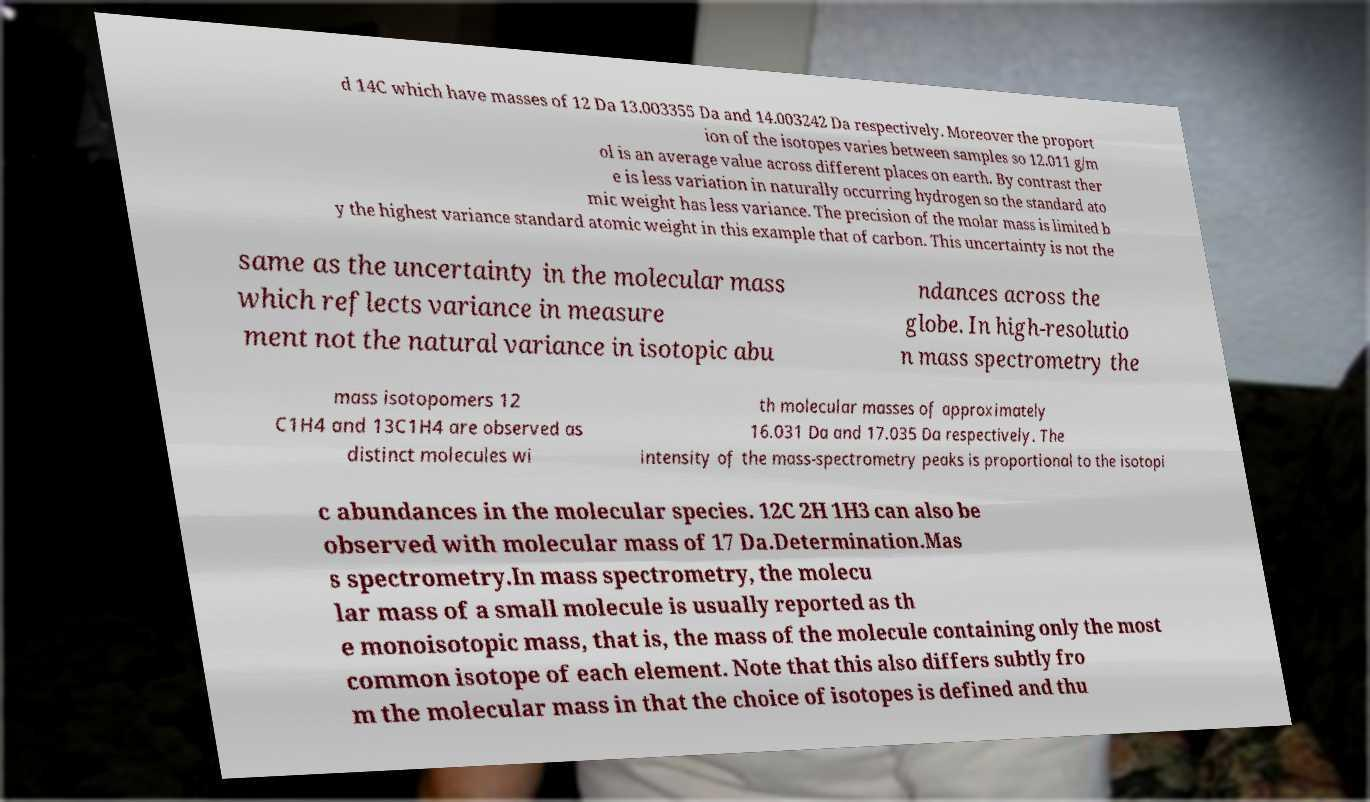Please read and relay the text visible in this image. What does it say? d 14C which have masses of 12 Da 13.003355 Da and 14.003242 Da respectively. Moreover the proport ion of the isotopes varies between samples so 12.011 g/m ol is an average value across different places on earth. By contrast ther e is less variation in naturally occurring hydrogen so the standard ato mic weight has less variance. The precision of the molar mass is limited b y the highest variance standard atomic weight in this example that of carbon. This uncertainty is not the same as the uncertainty in the molecular mass which reflects variance in measure ment not the natural variance in isotopic abu ndances across the globe. In high-resolutio n mass spectrometry the mass isotopomers 12 C1H4 and 13C1H4 are observed as distinct molecules wi th molecular masses of approximately 16.031 Da and 17.035 Da respectively. The intensity of the mass-spectrometry peaks is proportional to the isotopi c abundances in the molecular species. 12C 2H 1H3 can also be observed with molecular mass of 17 Da.Determination.Mas s spectrometry.In mass spectrometry, the molecu lar mass of a small molecule is usually reported as th e monoisotopic mass, that is, the mass of the molecule containing only the most common isotope of each element. Note that this also differs subtly fro m the molecular mass in that the choice of isotopes is defined and thu 